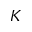<formula> <loc_0><loc_0><loc_500><loc_500>K</formula> 